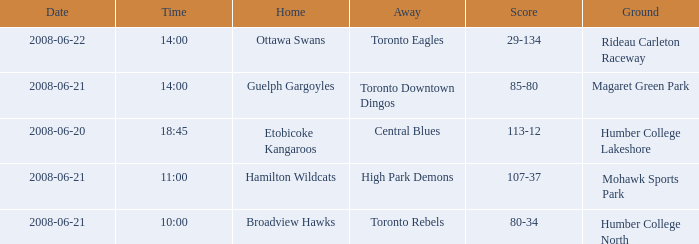What is the Away with a Ground that is humber college lakeshore? Central Blues. 